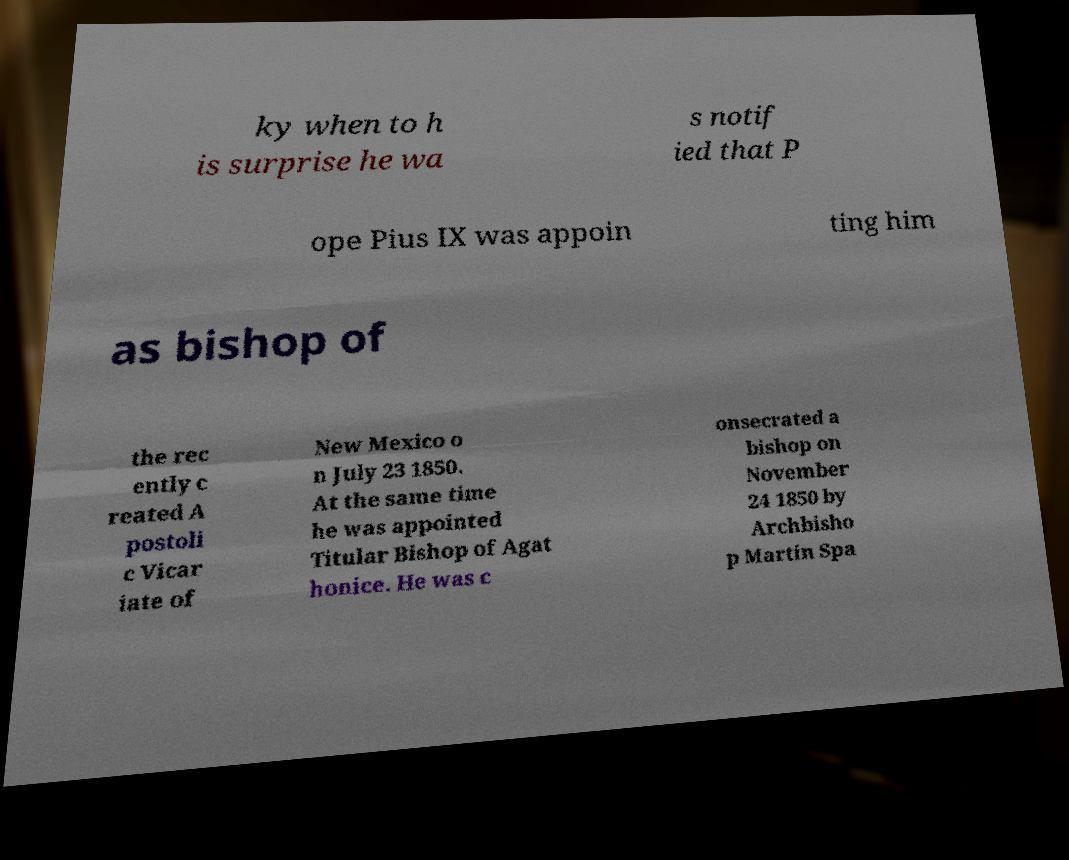There's text embedded in this image that I need extracted. Can you transcribe it verbatim? ky when to h is surprise he wa s notif ied that P ope Pius IX was appoin ting him as bishop of the rec ently c reated A postoli c Vicar iate of New Mexico o n July 23 1850. At the same time he was appointed Titular Bishop of Agat honice. He was c onsecrated a bishop on November 24 1850 by Archbisho p Martin Spa 